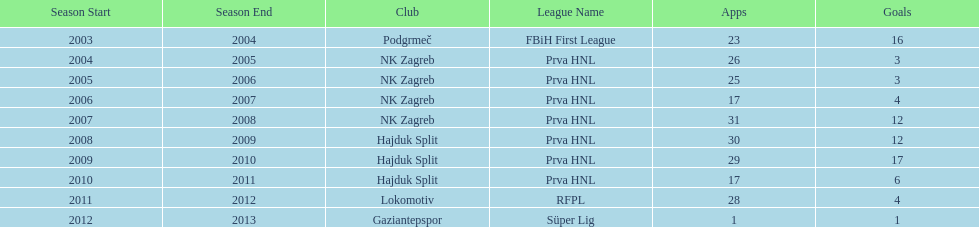Would you mind parsing the complete table? {'header': ['Season Start', 'Season End', 'Club', 'League Name', 'Apps', 'Goals'], 'rows': [['2003', '2004', 'Podgrmeč', 'FBiH First League', '23', '16'], ['2004', '2005', 'NK Zagreb', 'Prva HNL', '26', '3'], ['2005', '2006', 'NK Zagreb', 'Prva HNL', '25', '3'], ['2006', '2007', 'NK Zagreb', 'Prva HNL', '17', '4'], ['2007', '2008', 'NK Zagreb', 'Prva HNL', '31', '12'], ['2008', '2009', 'Hajduk Split', 'Prva HNL', '30', '12'], ['2009', '2010', 'Hajduk Split', 'Prva HNL', '29', '17'], ['2010', '2011', 'Hajduk Split', 'Prva HNL', '17', '6'], ['2011', '2012', 'Lokomotiv', 'RFPL', '28', '4'], ['2012', '2013', 'Gaziantepspor', 'Süper Lig', '1', '1']]} What is the highest number of goals scored by senijad ibri&#269;i&#263; in a season? 35. 